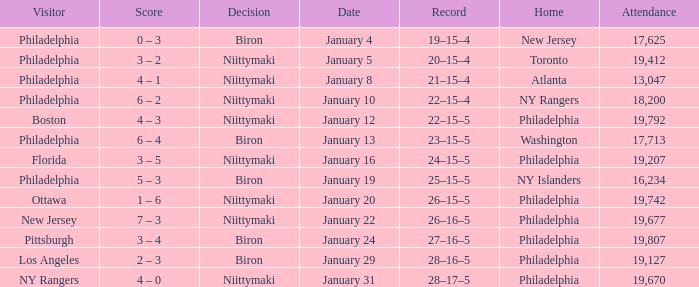Which team was the visitor on January 10? Philadelphia. 